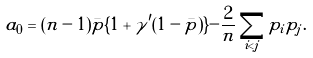<formula> <loc_0><loc_0><loc_500><loc_500>a _ { 0 } = ( n - 1 ) \bar { p } \{ 1 + \gamma ^ { \prime } ( 1 - \bar { p } ) \} - \frac { 2 } { n } \sum _ { i < j } p _ { i } p _ { j } .</formula> 